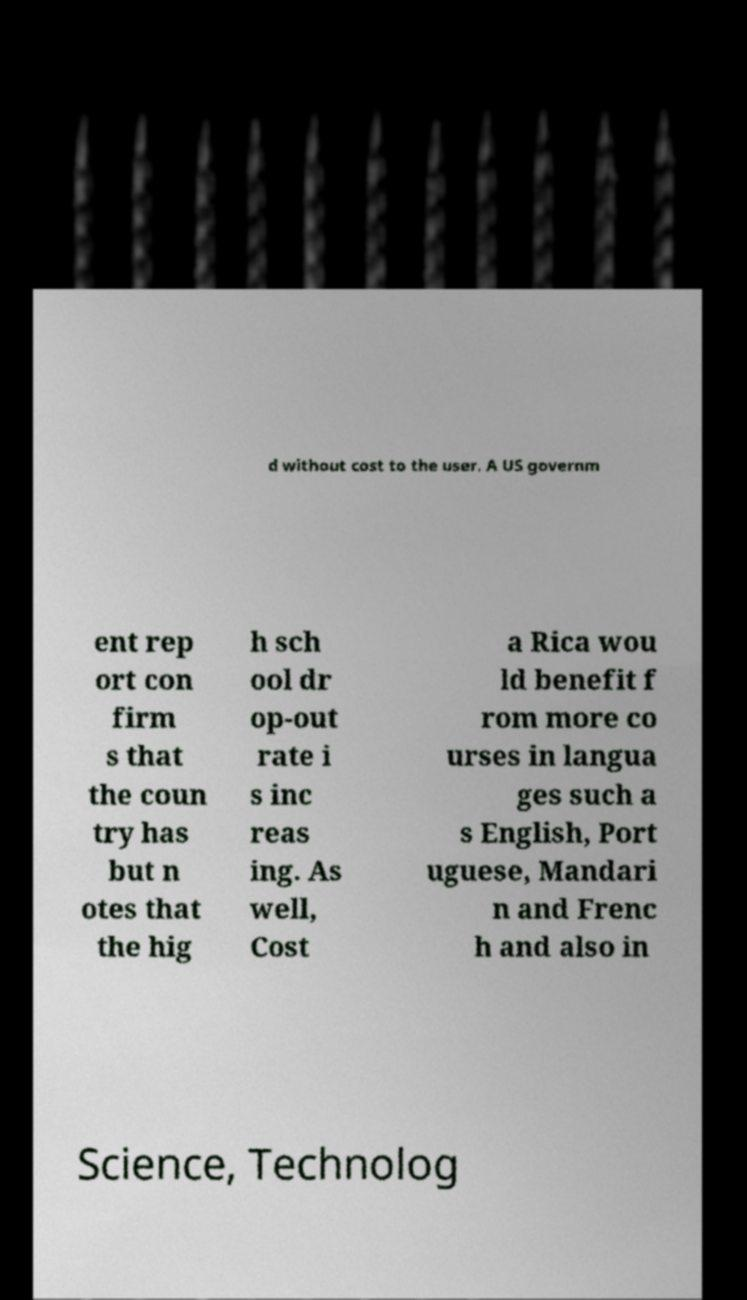Can you read and provide the text displayed in the image?This photo seems to have some interesting text. Can you extract and type it out for me? d without cost to the user. A US governm ent rep ort con firm s that the coun try has but n otes that the hig h sch ool dr op-out rate i s inc reas ing. As well, Cost a Rica wou ld benefit f rom more co urses in langua ges such a s English, Port uguese, Mandari n and Frenc h and also in Science, Technolog 